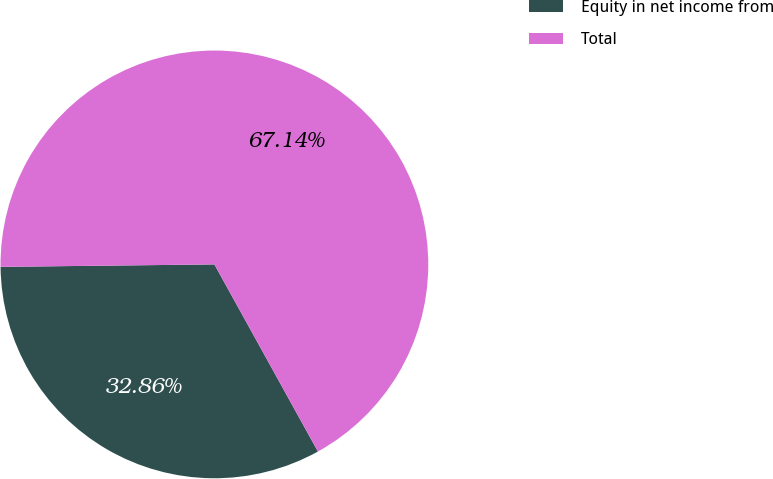Convert chart to OTSL. <chart><loc_0><loc_0><loc_500><loc_500><pie_chart><fcel>Equity in net income from<fcel>Total<nl><fcel>32.86%<fcel>67.14%<nl></chart> 